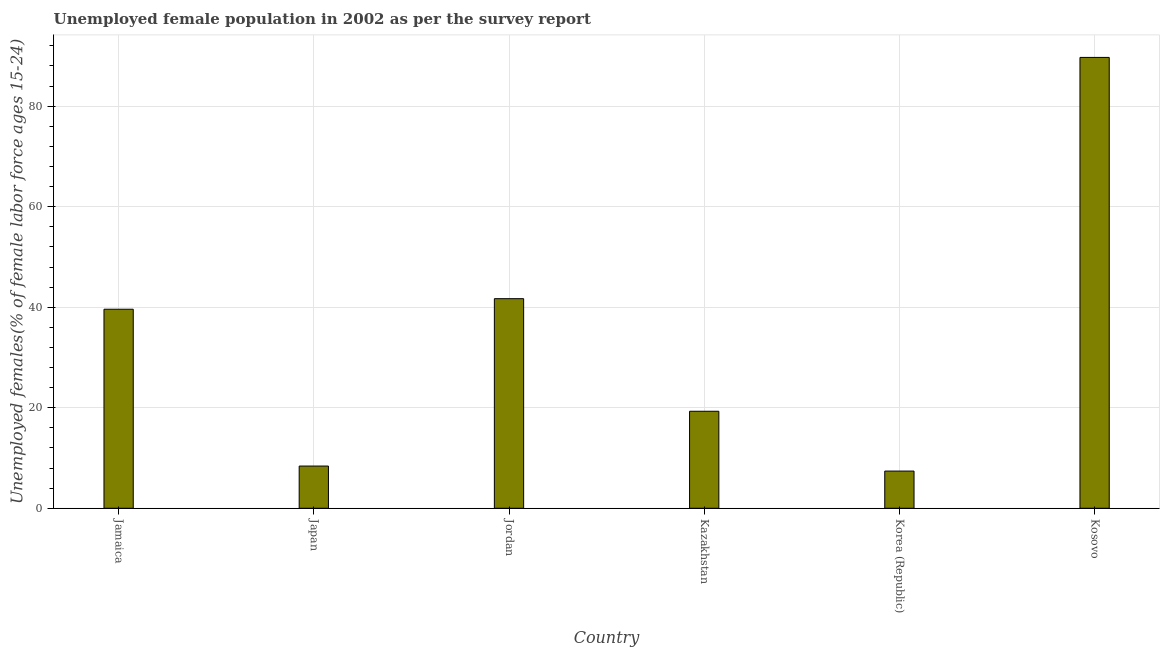What is the title of the graph?
Make the answer very short. Unemployed female population in 2002 as per the survey report. What is the label or title of the Y-axis?
Make the answer very short. Unemployed females(% of female labor force ages 15-24). What is the unemployed female youth in Japan?
Your answer should be very brief. 8.4. Across all countries, what is the maximum unemployed female youth?
Keep it short and to the point. 89.7. Across all countries, what is the minimum unemployed female youth?
Ensure brevity in your answer.  7.4. In which country was the unemployed female youth maximum?
Offer a very short reply. Kosovo. What is the sum of the unemployed female youth?
Keep it short and to the point. 206.1. What is the difference between the unemployed female youth in Japan and Jordan?
Make the answer very short. -33.3. What is the average unemployed female youth per country?
Give a very brief answer. 34.35. What is the median unemployed female youth?
Offer a terse response. 29.45. What is the ratio of the unemployed female youth in Jamaica to that in Kosovo?
Your answer should be compact. 0.44. Is the unemployed female youth in Jamaica less than that in Japan?
Your answer should be compact. No. Is the sum of the unemployed female youth in Jamaica and Kazakhstan greater than the maximum unemployed female youth across all countries?
Offer a very short reply. No. What is the difference between the highest and the lowest unemployed female youth?
Your answer should be compact. 82.3. Are all the bars in the graph horizontal?
Provide a succinct answer. No. How many countries are there in the graph?
Make the answer very short. 6. What is the difference between two consecutive major ticks on the Y-axis?
Give a very brief answer. 20. Are the values on the major ticks of Y-axis written in scientific E-notation?
Keep it short and to the point. No. What is the Unemployed females(% of female labor force ages 15-24) in Jamaica?
Your response must be concise. 39.6. What is the Unemployed females(% of female labor force ages 15-24) in Japan?
Your answer should be compact. 8.4. What is the Unemployed females(% of female labor force ages 15-24) of Jordan?
Your answer should be compact. 41.7. What is the Unemployed females(% of female labor force ages 15-24) in Kazakhstan?
Your answer should be very brief. 19.3. What is the Unemployed females(% of female labor force ages 15-24) in Korea (Republic)?
Provide a short and direct response. 7.4. What is the Unemployed females(% of female labor force ages 15-24) of Kosovo?
Make the answer very short. 89.7. What is the difference between the Unemployed females(% of female labor force ages 15-24) in Jamaica and Japan?
Provide a succinct answer. 31.2. What is the difference between the Unemployed females(% of female labor force ages 15-24) in Jamaica and Jordan?
Make the answer very short. -2.1. What is the difference between the Unemployed females(% of female labor force ages 15-24) in Jamaica and Kazakhstan?
Make the answer very short. 20.3. What is the difference between the Unemployed females(% of female labor force ages 15-24) in Jamaica and Korea (Republic)?
Your answer should be compact. 32.2. What is the difference between the Unemployed females(% of female labor force ages 15-24) in Jamaica and Kosovo?
Your response must be concise. -50.1. What is the difference between the Unemployed females(% of female labor force ages 15-24) in Japan and Jordan?
Ensure brevity in your answer.  -33.3. What is the difference between the Unemployed females(% of female labor force ages 15-24) in Japan and Kazakhstan?
Ensure brevity in your answer.  -10.9. What is the difference between the Unemployed females(% of female labor force ages 15-24) in Japan and Korea (Republic)?
Make the answer very short. 1. What is the difference between the Unemployed females(% of female labor force ages 15-24) in Japan and Kosovo?
Keep it short and to the point. -81.3. What is the difference between the Unemployed females(% of female labor force ages 15-24) in Jordan and Kazakhstan?
Your answer should be compact. 22.4. What is the difference between the Unemployed females(% of female labor force ages 15-24) in Jordan and Korea (Republic)?
Provide a short and direct response. 34.3. What is the difference between the Unemployed females(% of female labor force ages 15-24) in Jordan and Kosovo?
Provide a short and direct response. -48. What is the difference between the Unemployed females(% of female labor force ages 15-24) in Kazakhstan and Kosovo?
Provide a succinct answer. -70.4. What is the difference between the Unemployed females(% of female labor force ages 15-24) in Korea (Republic) and Kosovo?
Provide a short and direct response. -82.3. What is the ratio of the Unemployed females(% of female labor force ages 15-24) in Jamaica to that in Japan?
Ensure brevity in your answer.  4.71. What is the ratio of the Unemployed females(% of female labor force ages 15-24) in Jamaica to that in Jordan?
Keep it short and to the point. 0.95. What is the ratio of the Unemployed females(% of female labor force ages 15-24) in Jamaica to that in Kazakhstan?
Offer a terse response. 2.05. What is the ratio of the Unemployed females(% of female labor force ages 15-24) in Jamaica to that in Korea (Republic)?
Provide a short and direct response. 5.35. What is the ratio of the Unemployed females(% of female labor force ages 15-24) in Jamaica to that in Kosovo?
Give a very brief answer. 0.44. What is the ratio of the Unemployed females(% of female labor force ages 15-24) in Japan to that in Jordan?
Your answer should be compact. 0.2. What is the ratio of the Unemployed females(% of female labor force ages 15-24) in Japan to that in Kazakhstan?
Offer a very short reply. 0.43. What is the ratio of the Unemployed females(% of female labor force ages 15-24) in Japan to that in Korea (Republic)?
Your answer should be compact. 1.14. What is the ratio of the Unemployed females(% of female labor force ages 15-24) in Japan to that in Kosovo?
Provide a succinct answer. 0.09. What is the ratio of the Unemployed females(% of female labor force ages 15-24) in Jordan to that in Kazakhstan?
Your response must be concise. 2.16. What is the ratio of the Unemployed females(% of female labor force ages 15-24) in Jordan to that in Korea (Republic)?
Your answer should be very brief. 5.63. What is the ratio of the Unemployed females(% of female labor force ages 15-24) in Jordan to that in Kosovo?
Your answer should be very brief. 0.47. What is the ratio of the Unemployed females(% of female labor force ages 15-24) in Kazakhstan to that in Korea (Republic)?
Make the answer very short. 2.61. What is the ratio of the Unemployed females(% of female labor force ages 15-24) in Kazakhstan to that in Kosovo?
Your response must be concise. 0.21. What is the ratio of the Unemployed females(% of female labor force ages 15-24) in Korea (Republic) to that in Kosovo?
Make the answer very short. 0.08. 